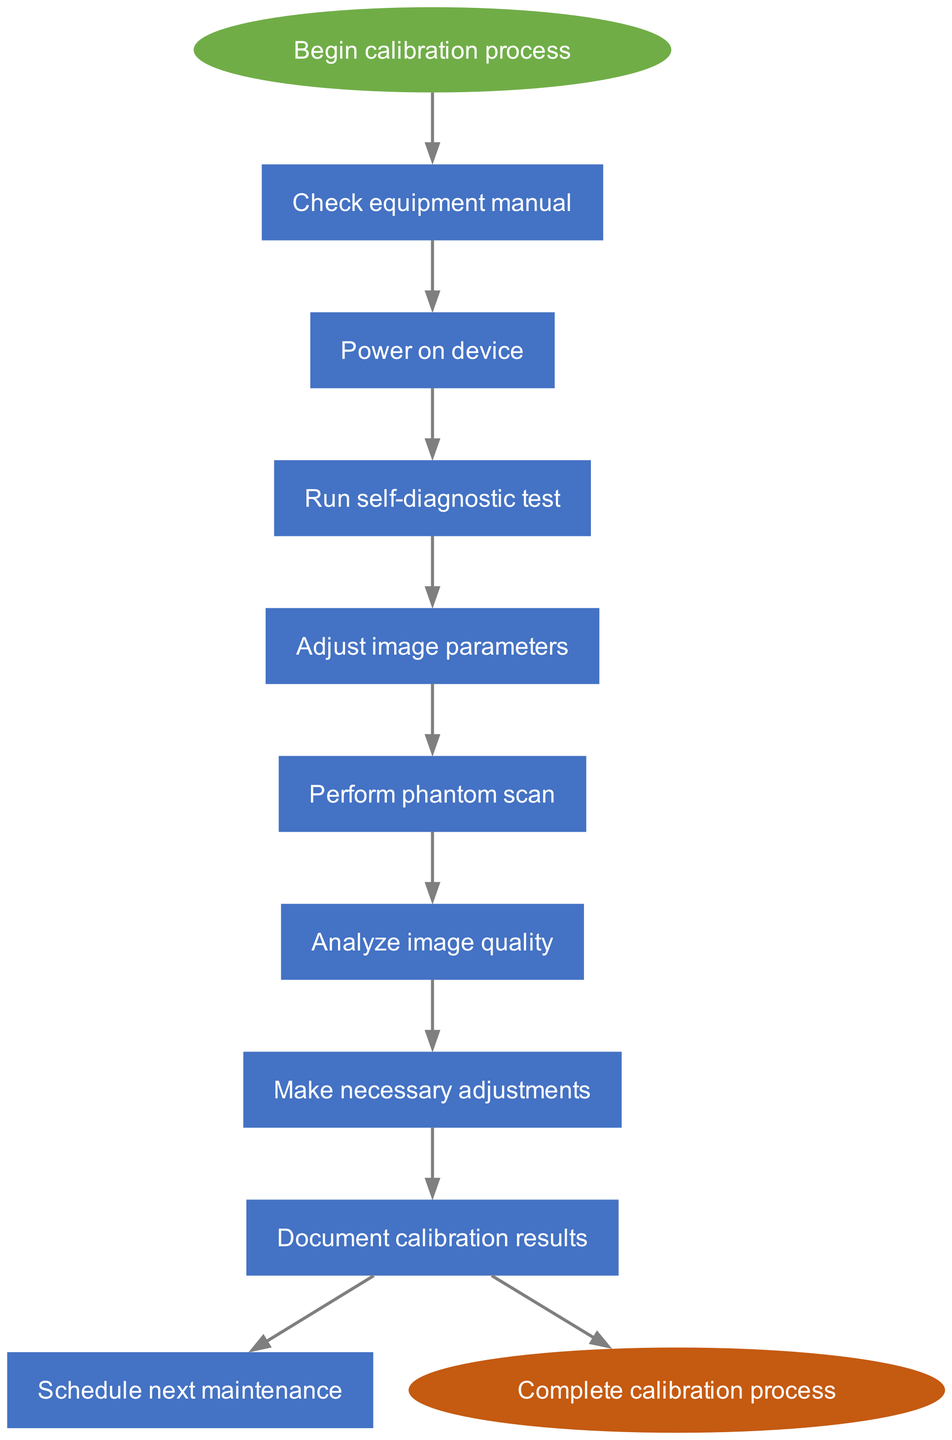What is the first step in the calibration process? The diagram shows that the first step is to "Check equipment manual" immediately after starting the calibration process.
Answer: Check equipment manual How many steps are involved in the calibration process? Counting each step listed in the diagram, there are a total of 8 steps from "Check equipment manual" to "Document calibration results."
Answer: 8 What step comes after "Perform phantom scan"? The diagram indicates that after "Perform phantom scan," the next step is "Analyze image quality."
Answer: Analyze image quality What is the last step before completing the calibration process? According to the flowchart, the last step before reaching the end is "Document calibration results." This node connects to the final "Complete calibration process" node.
Answer: Document calibration results Which step directly follows "Make necessary adjustments"? The diagram clearly shows that the next step that follows "Make necessary adjustments" is "Document calibration results."
Answer: Document calibration results What is the relationship between "Run self-diagnostic test" and "Power on device"? The flowchart shows that "Run self-diagnostic test" is dependent on the previous step, which is "Power on device," indicating a sequential flow between these two steps.
Answer: Sequential If you have completed all the steps, what final action is indicated? After finishing the steps in the calibration process, the diagram states that you will "Complete calibration process" as the final action.
Answer: Complete calibration process Is there any step that mentions scheduling? Yes, the diagram includes the step "Schedule next maintenance" which indicates that scheduling is part of the calibration process.
Answer: Schedule next maintenance How many edges connect the steps in the diagram? Since each step connects to the next in a consecutive manner and counting the edges between the nodes, there are a total of 8 directed edges from the start to the end.
Answer: 8 